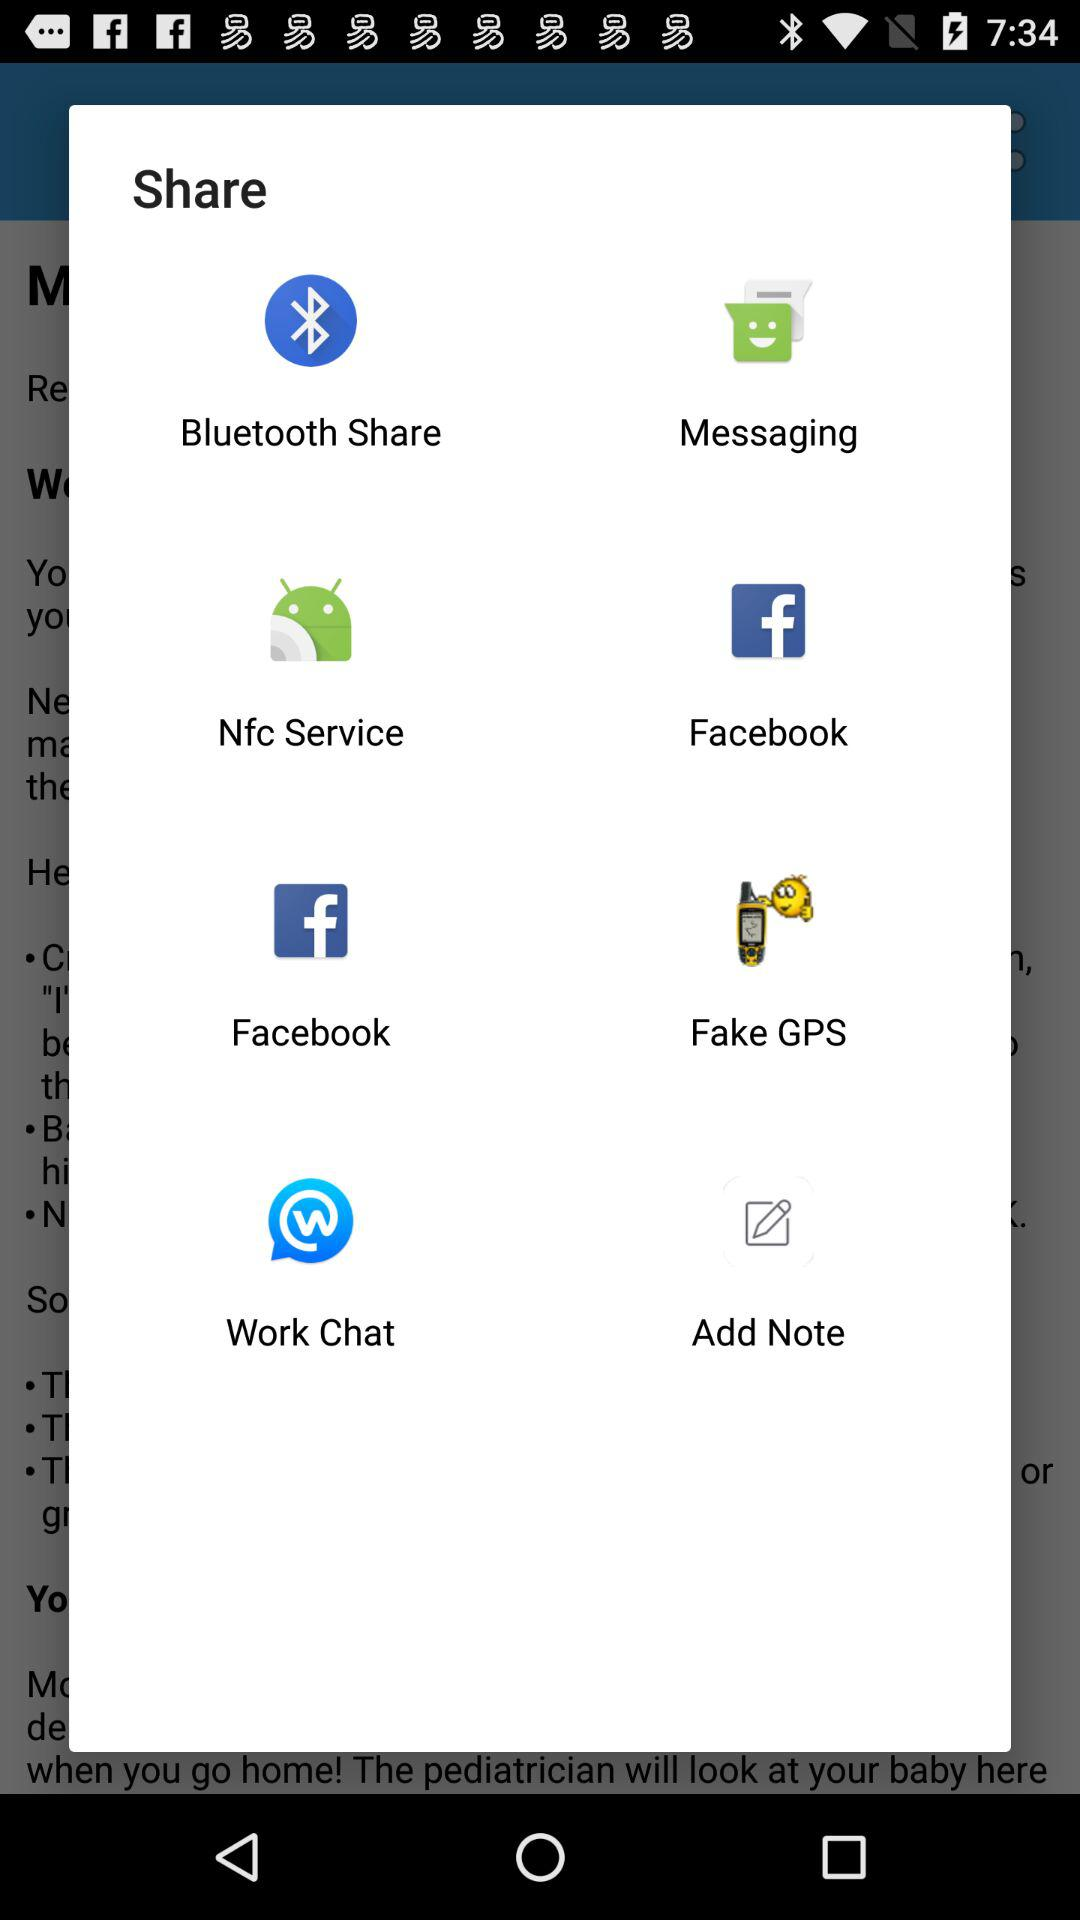Which application to choose to share? The applications to choose to share are "Bluetooth Share", "Messaging", "Nfc Service", "Facebook", "Fake GPS", "Work Chat" and "Add Note". 